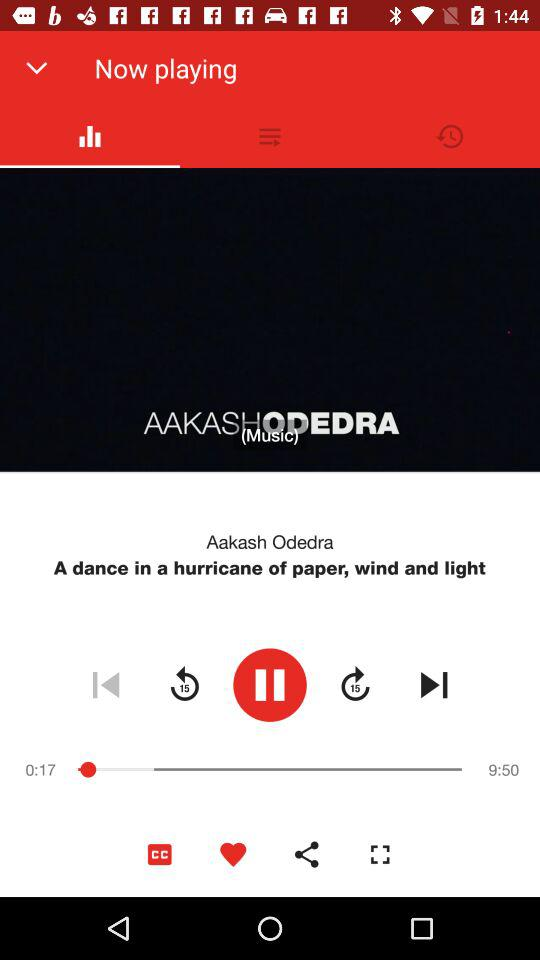How much of the song has been played? The song has been played for 17 seconds. 